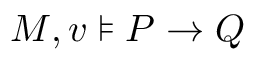<formula> <loc_0><loc_0><loc_500><loc_500>M , v \models P \rightarrow Q</formula> 